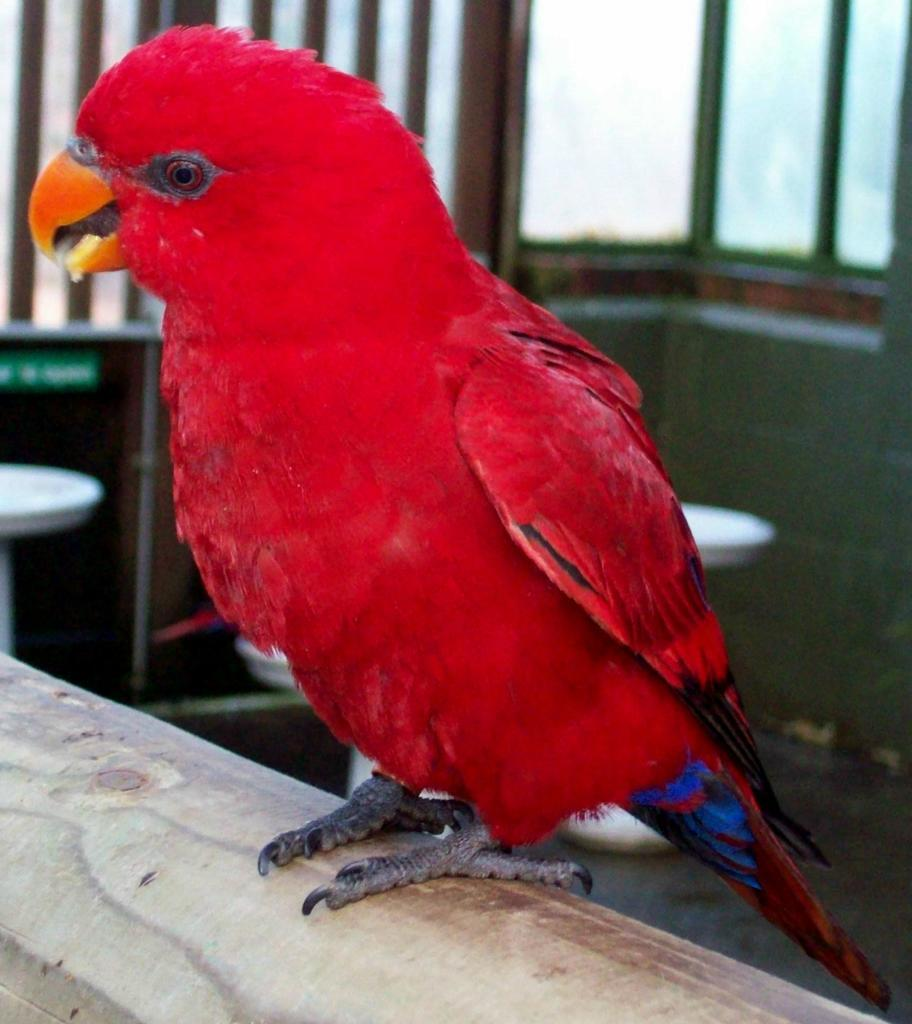What type of bird can be seen in the image? There is a red color bird in the image. What is the bird standing on? The bird is standing on a wooden surface. What color is the background behind the bird? The background of the bird is blue. What type of liquid is being poured from the horse's mouth in the image? There is no horse or liquid present in the image; it features a red color bird standing on a wooden surface with a blue background. 